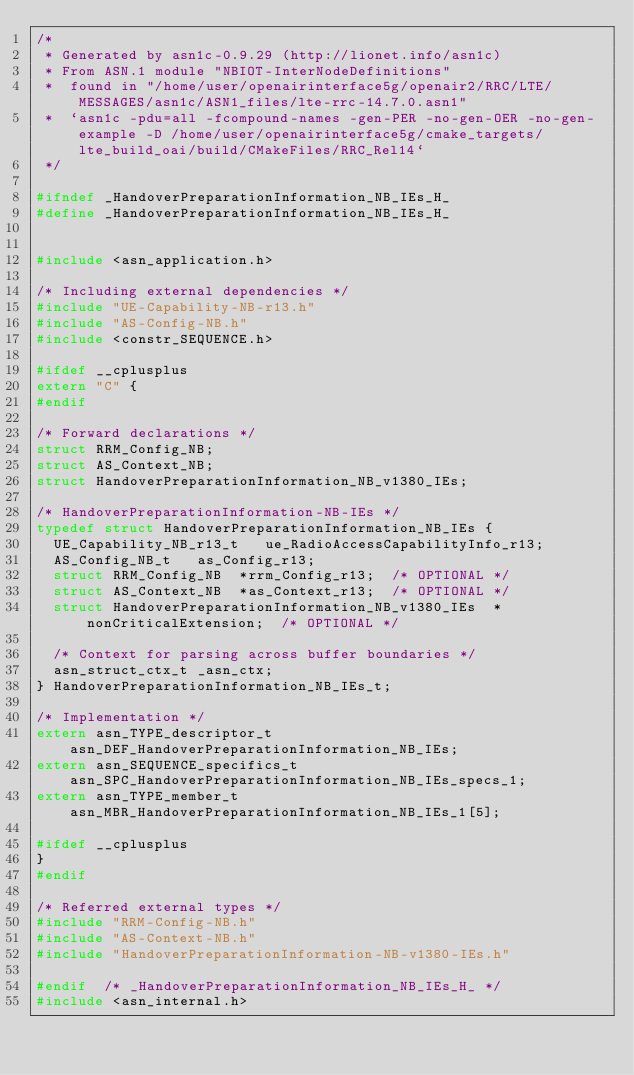Convert code to text. <code><loc_0><loc_0><loc_500><loc_500><_C_>/*
 * Generated by asn1c-0.9.29 (http://lionet.info/asn1c)
 * From ASN.1 module "NBIOT-InterNodeDefinitions"
 * 	found in "/home/user/openairinterface5g/openair2/RRC/LTE/MESSAGES/asn1c/ASN1_files/lte-rrc-14.7.0.asn1"
 * 	`asn1c -pdu=all -fcompound-names -gen-PER -no-gen-OER -no-gen-example -D /home/user/openairinterface5g/cmake_targets/lte_build_oai/build/CMakeFiles/RRC_Rel14`
 */

#ifndef	_HandoverPreparationInformation_NB_IEs_H_
#define	_HandoverPreparationInformation_NB_IEs_H_


#include <asn_application.h>

/* Including external dependencies */
#include "UE-Capability-NB-r13.h"
#include "AS-Config-NB.h"
#include <constr_SEQUENCE.h>

#ifdef __cplusplus
extern "C" {
#endif

/* Forward declarations */
struct RRM_Config_NB;
struct AS_Context_NB;
struct HandoverPreparationInformation_NB_v1380_IEs;

/* HandoverPreparationInformation-NB-IEs */
typedef struct HandoverPreparationInformation_NB_IEs {
	UE_Capability_NB_r13_t	 ue_RadioAccessCapabilityInfo_r13;
	AS_Config_NB_t	 as_Config_r13;
	struct RRM_Config_NB	*rrm_Config_r13;	/* OPTIONAL */
	struct AS_Context_NB	*as_Context_r13;	/* OPTIONAL */
	struct HandoverPreparationInformation_NB_v1380_IEs	*nonCriticalExtension;	/* OPTIONAL */
	
	/* Context for parsing across buffer boundaries */
	asn_struct_ctx_t _asn_ctx;
} HandoverPreparationInformation_NB_IEs_t;

/* Implementation */
extern asn_TYPE_descriptor_t asn_DEF_HandoverPreparationInformation_NB_IEs;
extern asn_SEQUENCE_specifics_t asn_SPC_HandoverPreparationInformation_NB_IEs_specs_1;
extern asn_TYPE_member_t asn_MBR_HandoverPreparationInformation_NB_IEs_1[5];

#ifdef __cplusplus
}
#endif

/* Referred external types */
#include "RRM-Config-NB.h"
#include "AS-Context-NB.h"
#include "HandoverPreparationInformation-NB-v1380-IEs.h"

#endif	/* _HandoverPreparationInformation_NB_IEs_H_ */
#include <asn_internal.h>
</code> 